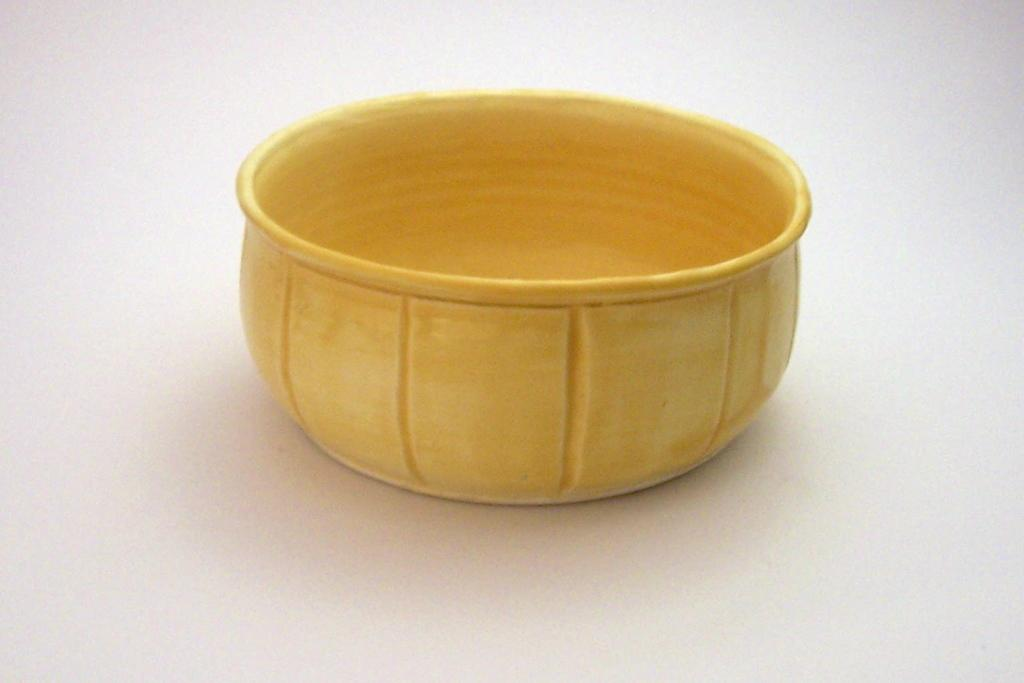What is the main object in the center of the image? There is a bowl in the center of the image. What is the color of the surface on which the bowl is placed? The bowl is on a white surface. How many cacti are present in the image? There are no cacti present in the image. 